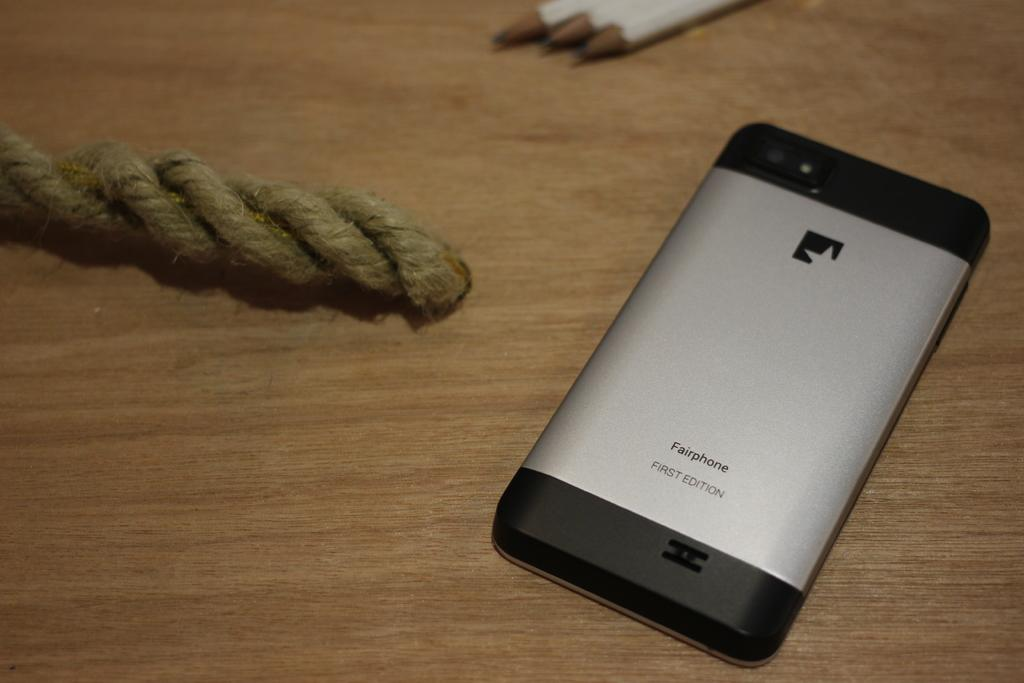Provide a one-sentence caption for the provided image. A first edition Fairphone is laying face down on a wooden surface. 